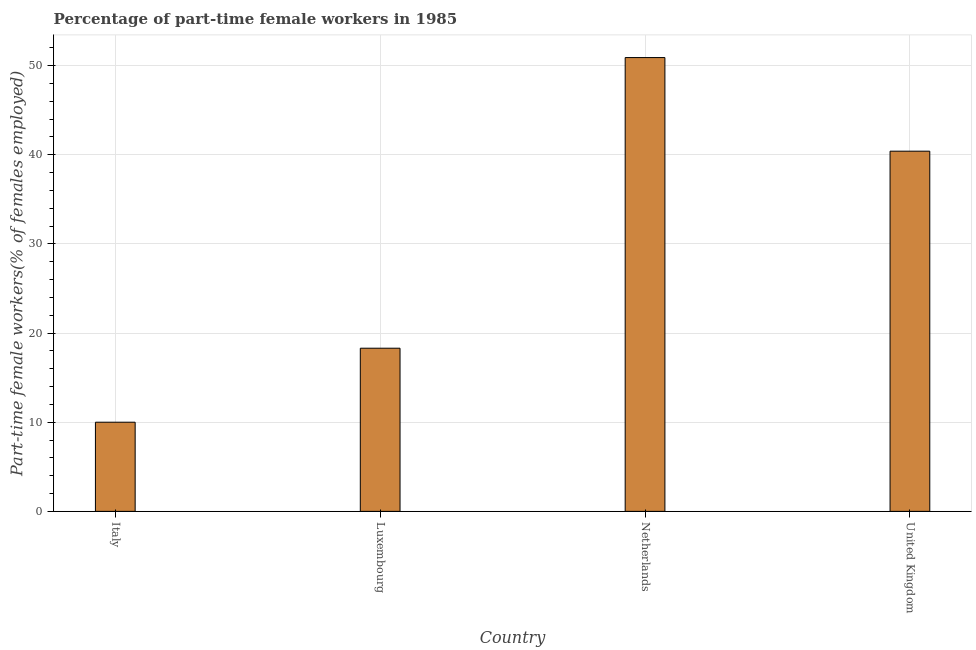What is the title of the graph?
Give a very brief answer. Percentage of part-time female workers in 1985. What is the label or title of the X-axis?
Offer a terse response. Country. What is the label or title of the Y-axis?
Provide a short and direct response. Part-time female workers(% of females employed). What is the percentage of part-time female workers in Italy?
Your answer should be very brief. 10. Across all countries, what is the maximum percentage of part-time female workers?
Your response must be concise. 50.9. Across all countries, what is the minimum percentage of part-time female workers?
Your answer should be compact. 10. In which country was the percentage of part-time female workers maximum?
Your answer should be very brief. Netherlands. In which country was the percentage of part-time female workers minimum?
Keep it short and to the point. Italy. What is the sum of the percentage of part-time female workers?
Offer a very short reply. 119.6. What is the difference between the percentage of part-time female workers in Luxembourg and Netherlands?
Your answer should be very brief. -32.6. What is the average percentage of part-time female workers per country?
Provide a short and direct response. 29.9. What is the median percentage of part-time female workers?
Provide a succinct answer. 29.35. In how many countries, is the percentage of part-time female workers greater than 44 %?
Provide a short and direct response. 1. What is the ratio of the percentage of part-time female workers in Italy to that in United Kingdom?
Give a very brief answer. 0.25. Is the percentage of part-time female workers in Luxembourg less than that in Netherlands?
Offer a terse response. Yes. What is the difference between the highest and the lowest percentage of part-time female workers?
Provide a short and direct response. 40.9. In how many countries, is the percentage of part-time female workers greater than the average percentage of part-time female workers taken over all countries?
Offer a terse response. 2. How many bars are there?
Your answer should be compact. 4. Are all the bars in the graph horizontal?
Make the answer very short. No. What is the difference between two consecutive major ticks on the Y-axis?
Make the answer very short. 10. What is the Part-time female workers(% of females employed) in Luxembourg?
Make the answer very short. 18.3. What is the Part-time female workers(% of females employed) of Netherlands?
Make the answer very short. 50.9. What is the Part-time female workers(% of females employed) of United Kingdom?
Offer a terse response. 40.4. What is the difference between the Part-time female workers(% of females employed) in Italy and Luxembourg?
Your answer should be very brief. -8.3. What is the difference between the Part-time female workers(% of females employed) in Italy and Netherlands?
Provide a short and direct response. -40.9. What is the difference between the Part-time female workers(% of females employed) in Italy and United Kingdom?
Give a very brief answer. -30.4. What is the difference between the Part-time female workers(% of females employed) in Luxembourg and Netherlands?
Make the answer very short. -32.6. What is the difference between the Part-time female workers(% of females employed) in Luxembourg and United Kingdom?
Your response must be concise. -22.1. What is the difference between the Part-time female workers(% of females employed) in Netherlands and United Kingdom?
Offer a very short reply. 10.5. What is the ratio of the Part-time female workers(% of females employed) in Italy to that in Luxembourg?
Provide a succinct answer. 0.55. What is the ratio of the Part-time female workers(% of females employed) in Italy to that in Netherlands?
Make the answer very short. 0.2. What is the ratio of the Part-time female workers(% of females employed) in Italy to that in United Kingdom?
Provide a short and direct response. 0.25. What is the ratio of the Part-time female workers(% of females employed) in Luxembourg to that in Netherlands?
Offer a very short reply. 0.36. What is the ratio of the Part-time female workers(% of females employed) in Luxembourg to that in United Kingdom?
Provide a succinct answer. 0.45. What is the ratio of the Part-time female workers(% of females employed) in Netherlands to that in United Kingdom?
Your answer should be very brief. 1.26. 